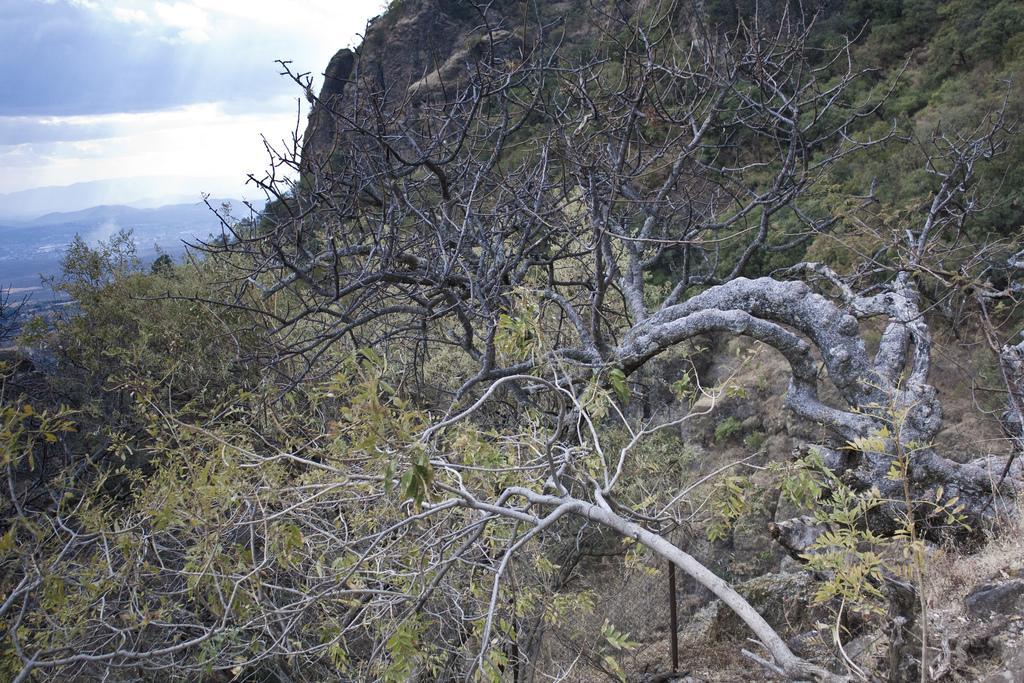Can you describe this image briefly? In this picture we can see the hills and trees. In the top left corner we can see the clouds in the sky. 